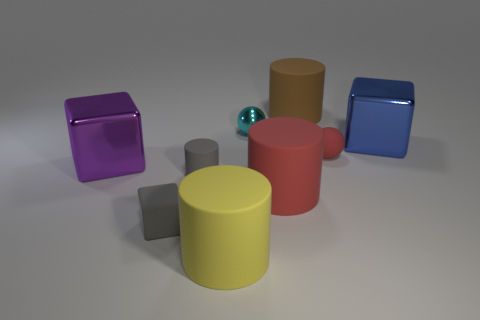There is a sphere that is the same size as the cyan metallic thing; what material is it?
Give a very brief answer. Rubber. What number of things are small gray rubber spheres or yellow things?
Offer a terse response. 1. How many large shiny objects are in front of the big blue metal block and behind the big purple object?
Your answer should be very brief. 0. Are there fewer balls that are on the left side of the large yellow thing than large green metallic things?
Your response must be concise. No. There is a red object that is the same size as the cyan thing; what is its shape?
Your answer should be very brief. Sphere. What number of other objects are there of the same color as the matte ball?
Give a very brief answer. 1. Do the gray matte cube and the brown cylinder have the same size?
Ensure brevity in your answer.  No. What number of things are large things or cubes in front of the tiny matte ball?
Provide a short and direct response. 6. Are there fewer purple blocks that are behind the blue thing than large cubes that are behind the big purple thing?
Make the answer very short. Yes. What number of other things are there of the same material as the red cylinder
Your answer should be very brief. 5. 